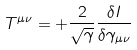Convert formula to latex. <formula><loc_0><loc_0><loc_500><loc_500>T ^ { \mu \nu } = + \frac { 2 } { \sqrt { \gamma } } \frac { \delta I } { \delta \gamma _ { \mu \nu } }</formula> 